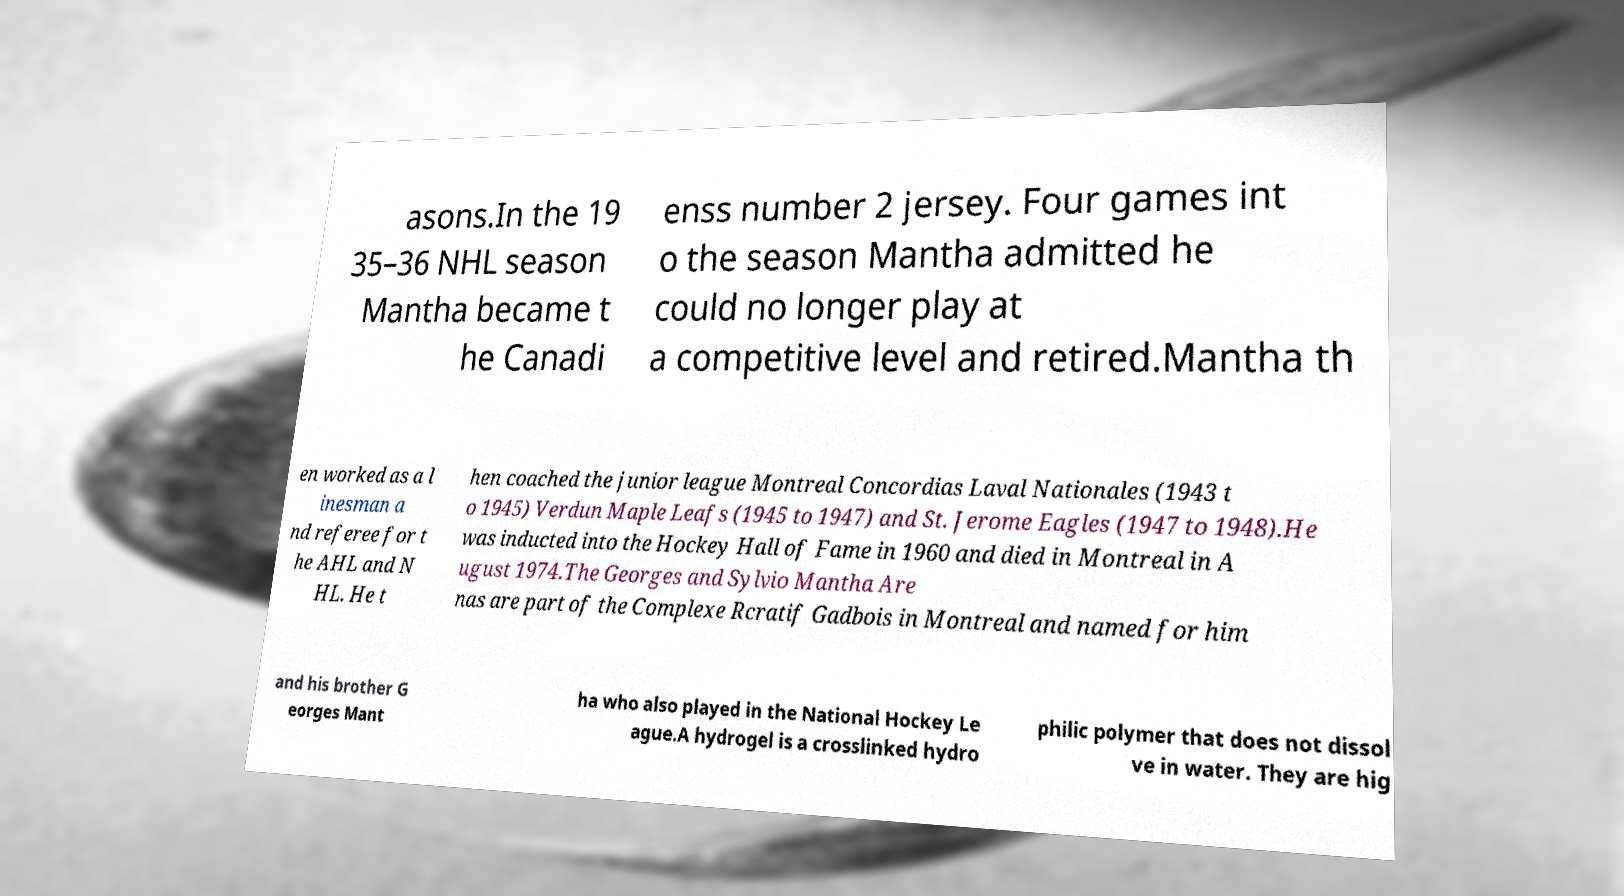Could you assist in decoding the text presented in this image and type it out clearly? asons.In the 19 35–36 NHL season Mantha became t he Canadi enss number 2 jersey. Four games int o the season Mantha admitted he could no longer play at a competitive level and retired.Mantha th en worked as a l inesman a nd referee for t he AHL and N HL. He t hen coached the junior league Montreal Concordias Laval Nationales (1943 t o 1945) Verdun Maple Leafs (1945 to 1947) and St. Jerome Eagles (1947 to 1948).He was inducted into the Hockey Hall of Fame in 1960 and died in Montreal in A ugust 1974.The Georges and Sylvio Mantha Are nas are part of the Complexe Rcratif Gadbois in Montreal and named for him and his brother G eorges Mant ha who also played in the National Hockey Le ague.A hydrogel is a crosslinked hydro philic polymer that does not dissol ve in water. They are hig 